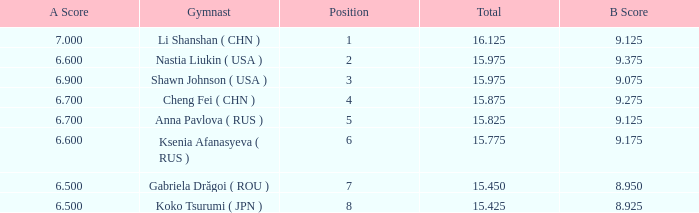What the B Score when the total is 16.125 and the position is less than 7? 9.125. 